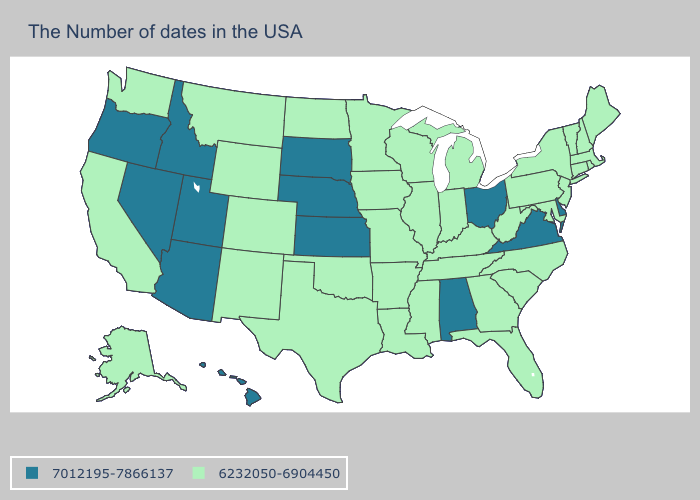Does the first symbol in the legend represent the smallest category?
Give a very brief answer. No. Does Utah have the lowest value in the West?
Give a very brief answer. No. What is the lowest value in the West?
Be succinct. 6232050-6904450. What is the value of Idaho?
Quick response, please. 7012195-7866137. Among the states that border Nebraska , which have the highest value?
Concise answer only. Kansas, South Dakota. Among the states that border Ohio , which have the lowest value?
Write a very short answer. Pennsylvania, West Virginia, Michigan, Kentucky, Indiana. What is the highest value in the South ?
Write a very short answer. 7012195-7866137. How many symbols are there in the legend?
Write a very short answer. 2. What is the value of Louisiana?
Answer briefly. 6232050-6904450. What is the value of Oregon?
Be succinct. 7012195-7866137. Which states have the highest value in the USA?
Short answer required. Delaware, Virginia, Ohio, Alabama, Kansas, Nebraska, South Dakota, Utah, Arizona, Idaho, Nevada, Oregon, Hawaii. Name the states that have a value in the range 6232050-6904450?
Keep it brief. Maine, Massachusetts, Rhode Island, New Hampshire, Vermont, Connecticut, New York, New Jersey, Maryland, Pennsylvania, North Carolina, South Carolina, West Virginia, Florida, Georgia, Michigan, Kentucky, Indiana, Tennessee, Wisconsin, Illinois, Mississippi, Louisiana, Missouri, Arkansas, Minnesota, Iowa, Oklahoma, Texas, North Dakota, Wyoming, Colorado, New Mexico, Montana, California, Washington, Alaska. Among the states that border Tennessee , does North Carolina have the highest value?
Keep it brief. No. What is the value of Wyoming?
Be succinct. 6232050-6904450. Which states have the lowest value in the USA?
Keep it brief. Maine, Massachusetts, Rhode Island, New Hampshire, Vermont, Connecticut, New York, New Jersey, Maryland, Pennsylvania, North Carolina, South Carolina, West Virginia, Florida, Georgia, Michigan, Kentucky, Indiana, Tennessee, Wisconsin, Illinois, Mississippi, Louisiana, Missouri, Arkansas, Minnesota, Iowa, Oklahoma, Texas, North Dakota, Wyoming, Colorado, New Mexico, Montana, California, Washington, Alaska. 